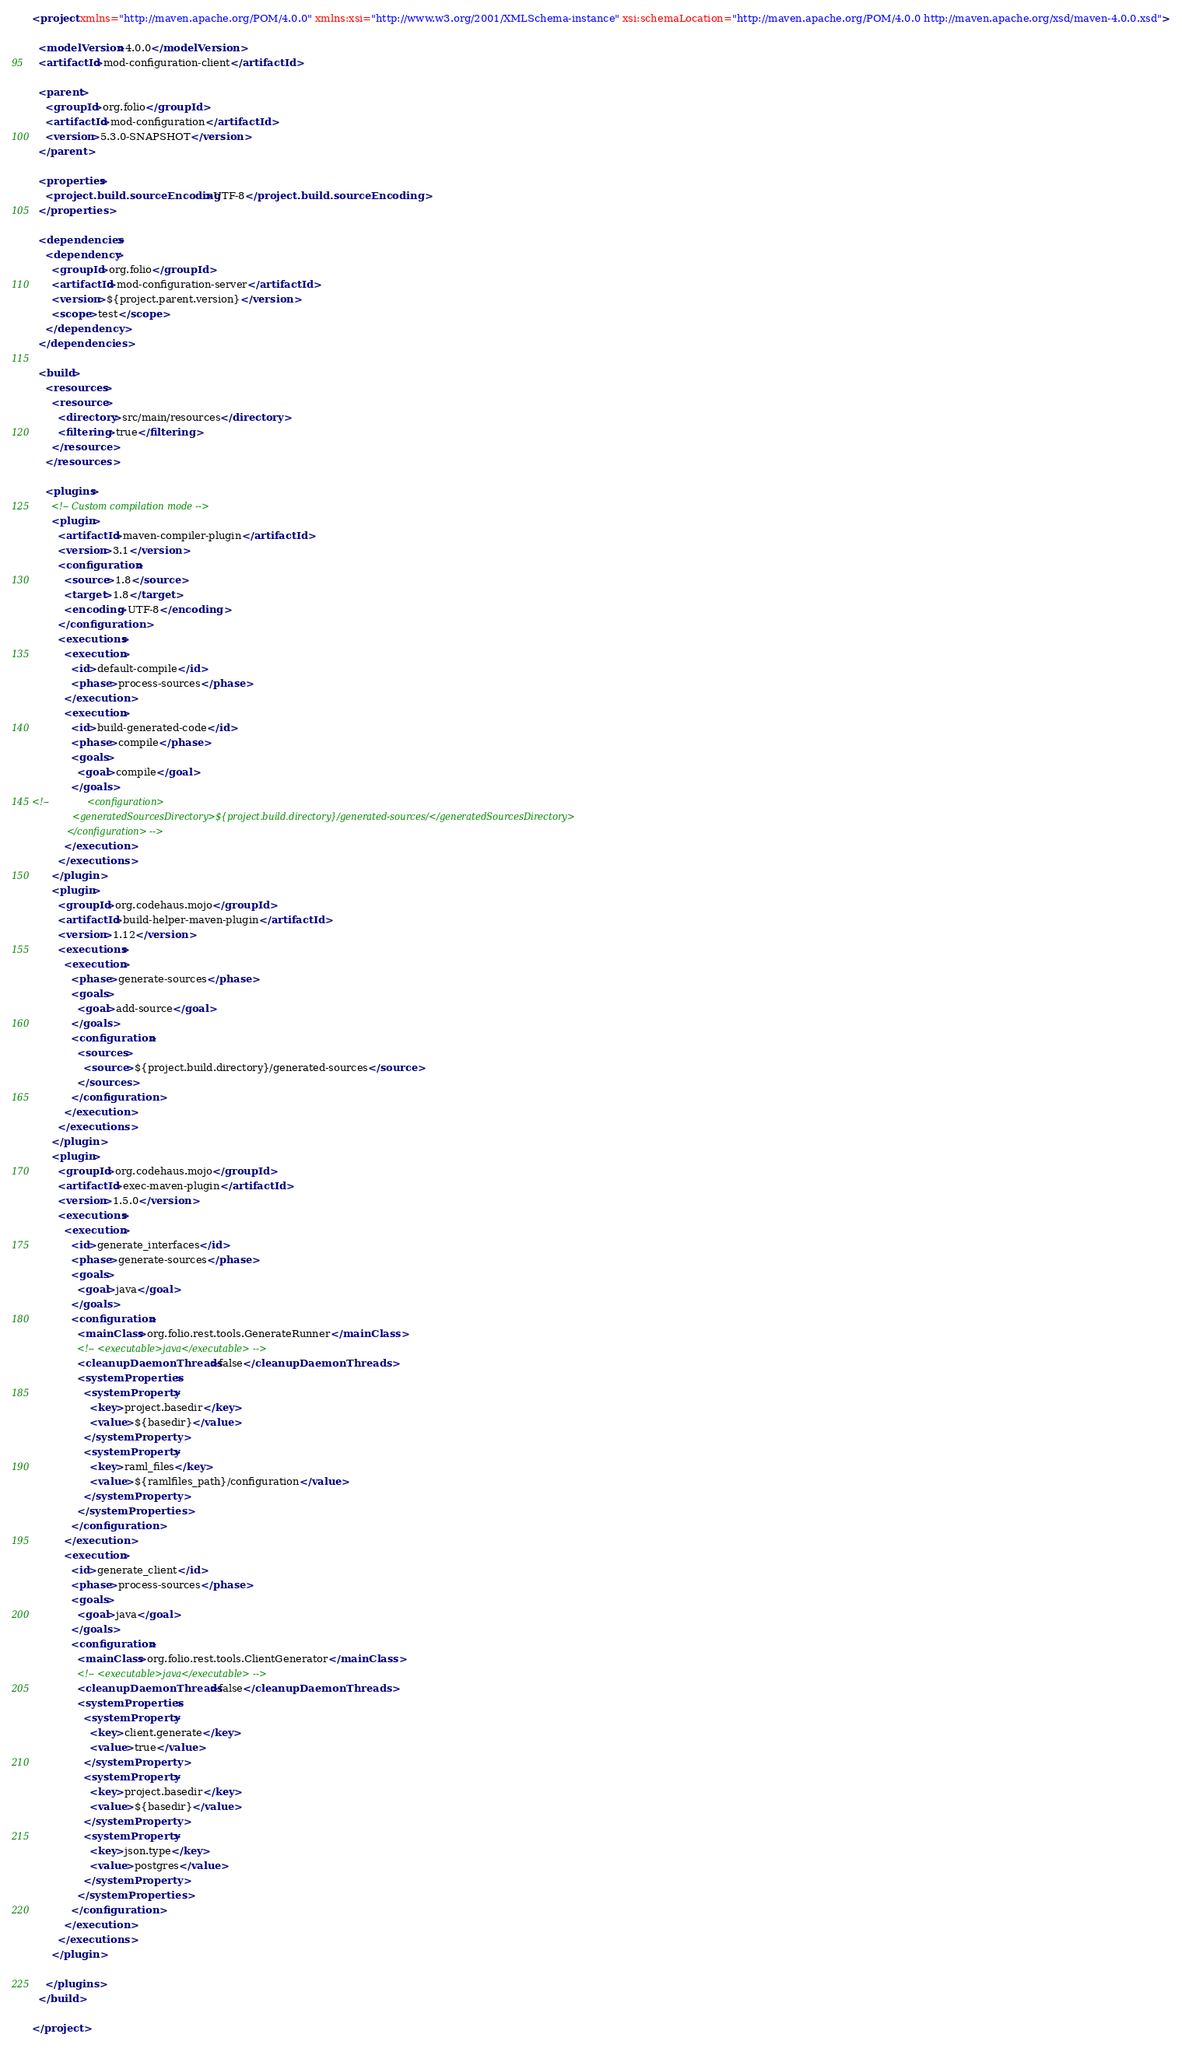Convert code to text. <code><loc_0><loc_0><loc_500><loc_500><_XML_><project xmlns="http://maven.apache.org/POM/4.0.0" xmlns:xsi="http://www.w3.org/2001/XMLSchema-instance" xsi:schemaLocation="http://maven.apache.org/POM/4.0.0 http://maven.apache.org/xsd/maven-4.0.0.xsd">

  <modelVersion>4.0.0</modelVersion>
  <artifactId>mod-configuration-client</artifactId>

  <parent>
    <groupId>org.folio</groupId>
    <artifactId>mod-configuration</artifactId>
    <version>5.3.0-SNAPSHOT</version>
  </parent>

  <properties>
    <project.build.sourceEncoding>UTF-8</project.build.sourceEncoding>
  </properties>

  <dependencies>
    <dependency>
      <groupId>org.folio</groupId>
      <artifactId>mod-configuration-server</artifactId>
      <version>${project.parent.version}</version>
      <scope>test</scope>
    </dependency>
  </dependencies>

  <build>
    <resources>
      <resource>
        <directory>src/main/resources</directory>
        <filtering>true</filtering>
      </resource>
    </resources>

    <plugins>
      <!-- Custom compilation mode -->
      <plugin>
        <artifactId>maven-compiler-plugin</artifactId>
        <version>3.1</version>
        <configuration>
          <source>1.8</source>
          <target>1.8</target>
          <encoding>UTF-8</encoding>
        </configuration>
        <executions>
          <execution>
            <id>default-compile</id>
            <phase>process-sources</phase>
          </execution>
          <execution>
            <id>build-generated-code</id>
            <phase>compile</phase>
            <goals>
              <goal>compile</goal>
            </goals>
<!--             <configuration>
              <generatedSourcesDirectory>${project.build.directory}/generated-sources/</generatedSourcesDirectory>
            </configuration> -->
          </execution>
        </executions>
      </plugin>
      <plugin>
        <groupId>org.codehaus.mojo</groupId>
        <artifactId>build-helper-maven-plugin</artifactId>
        <version>1.12</version>
        <executions>
          <execution>
            <phase>generate-sources</phase>
            <goals>
              <goal>add-source</goal>
            </goals>
            <configuration>
              <sources>
                <source>${project.build.directory}/generated-sources</source>
              </sources>
            </configuration>
          </execution>
        </executions>
      </plugin>
      <plugin>
        <groupId>org.codehaus.mojo</groupId>
        <artifactId>exec-maven-plugin</artifactId>
        <version>1.5.0</version>
        <executions>
          <execution>
            <id>generate_interfaces</id>
            <phase>generate-sources</phase>
            <goals>
              <goal>java</goal>
            </goals>
            <configuration>
              <mainClass>org.folio.rest.tools.GenerateRunner</mainClass>
              <!-- <executable>java</executable> -->
              <cleanupDaemonThreads>false</cleanupDaemonThreads>
              <systemProperties>
                <systemProperty>
                  <key>project.basedir</key>
                  <value>${basedir}</value>
                </systemProperty>
                <systemProperty>
                  <key>raml_files</key>
                  <value>${ramlfiles_path}/configuration</value>
                </systemProperty>
              </systemProperties>
            </configuration>
          </execution>
          <execution>
            <id>generate_client</id>
            <phase>process-sources</phase>
            <goals>
              <goal>java</goal>
            </goals>
            <configuration>
              <mainClass>org.folio.rest.tools.ClientGenerator</mainClass>
              <!-- <executable>java</executable> -->
              <cleanupDaemonThreads>false</cleanupDaemonThreads>
              <systemProperties>
                <systemProperty>
                  <key>client.generate</key>
                  <value>true</value>
                </systemProperty>
                <systemProperty>
                  <key>project.basedir</key>
                  <value>${basedir}</value>
                </systemProperty>
                <systemProperty>
                  <key>json.type</key>
                  <value>postgres</value>
                </systemProperty>
              </systemProperties>
            </configuration>
          </execution>
        </executions>
      </plugin>

    </plugins>
  </build>

</project>
</code> 